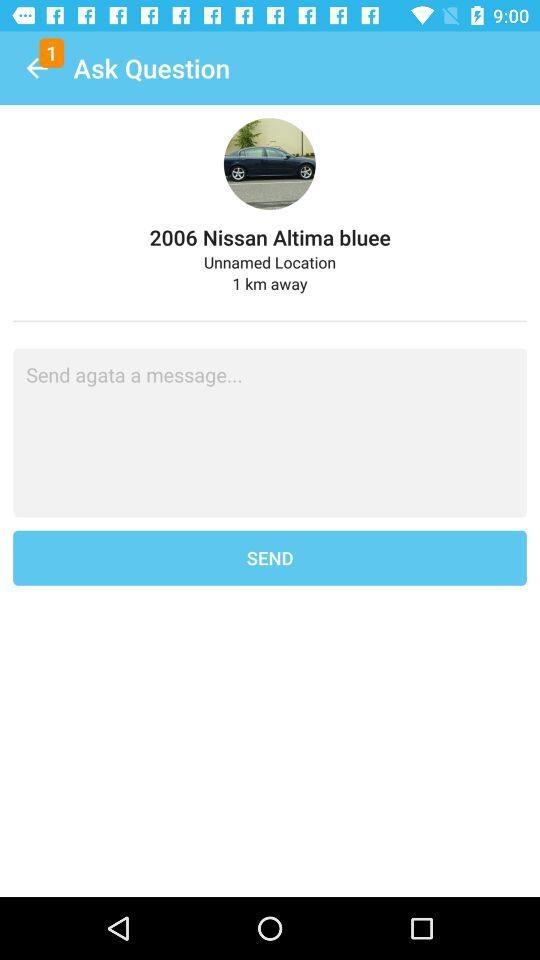What is the name of the car? The name of the car is "2006 Nissan Altima bluee". 